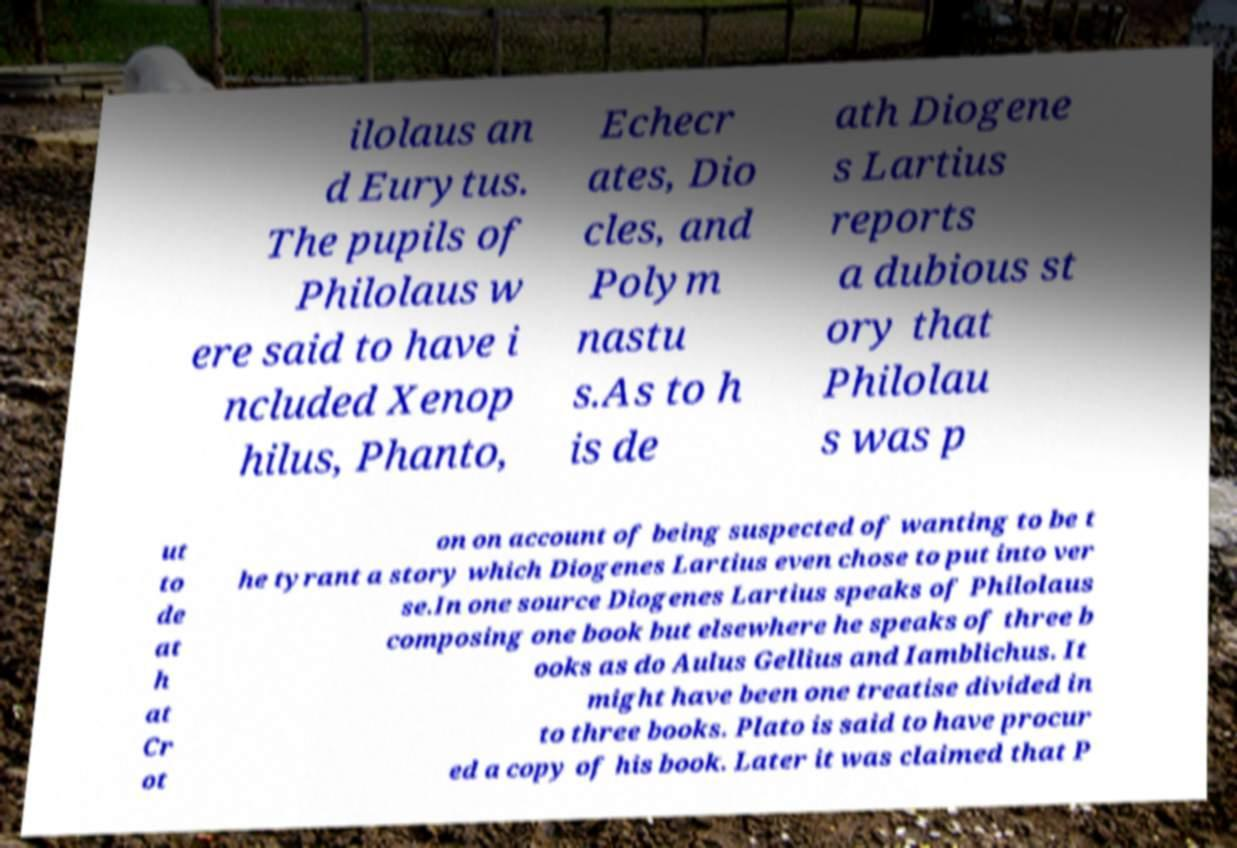Can you read and provide the text displayed in the image?This photo seems to have some interesting text. Can you extract and type it out for me? ilolaus an d Eurytus. The pupils of Philolaus w ere said to have i ncluded Xenop hilus, Phanto, Echecr ates, Dio cles, and Polym nastu s.As to h is de ath Diogene s Lartius reports a dubious st ory that Philolau s was p ut to de at h at Cr ot on on account of being suspected of wanting to be t he tyrant a story which Diogenes Lartius even chose to put into ver se.In one source Diogenes Lartius speaks of Philolaus composing one book but elsewhere he speaks of three b ooks as do Aulus Gellius and Iamblichus. It might have been one treatise divided in to three books. Plato is said to have procur ed a copy of his book. Later it was claimed that P 